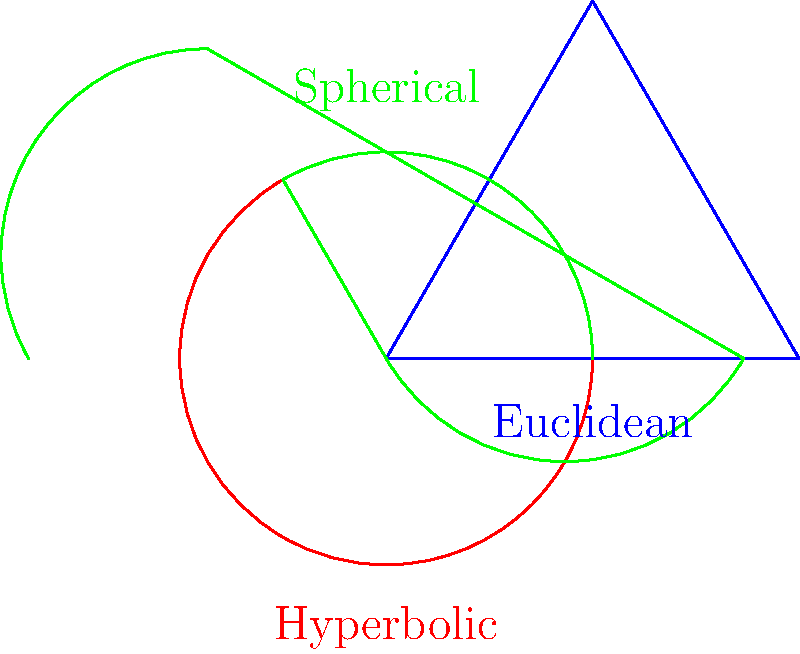In the context of Non-Euclidean Geometry, how does the sum of interior angles in triangles differ across Euclidean, hyperbolic, and spherical geometries? Relate this concept to the portrayal of spatial relationships in film and television, particularly in scenes involving curved or distorted spaces. 1. Euclidean Geometry:
   - In Euclidean geometry, the sum of interior angles of a triangle is always 180°.
   - Formula: $S_E = 180°$

2. Hyperbolic Geometry:
   - In hyperbolic geometry, the sum of interior angles is less than 180°.
   - Formula: $S_H = 180° - A$, where A is the area of the triangle in radians.

3. Spherical Geometry:
   - In spherical geometry, the sum of interior angles is greater than 180°.
   - Formula: $S_S = 180° + A$, where A is the area of the triangle in radians.

4. Comparison:
   $S_H < S_E < S_S$

5. Relation to film and television:
   - Euclidean geometry is used in most conventional scenes with flat surfaces.
   - Hyperbolic geometry can be used to portray warped spaces, like in "Interstellar" near black holes.
   - Spherical geometry is often used in fisheye lens shots or to represent planetary surfaces.

6. Dialectal representation:
   - The choice of geometry in visual media can reflect the cultural or linguistic background of the characters.
   - Non-Euclidean geometries might be used to represent "otherness" or unfamiliar environments in sci-fi or fantasy genres.
Answer: Euclidean: 180°; Hyperbolic: < 180°; Spherical: > 180°. In film, these geometries can represent normal, warped, and curved spaces respectively, potentially reflecting character perspectives or environments. 